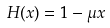<formula> <loc_0><loc_0><loc_500><loc_500>H ( x ) = 1 - \mu x</formula> 